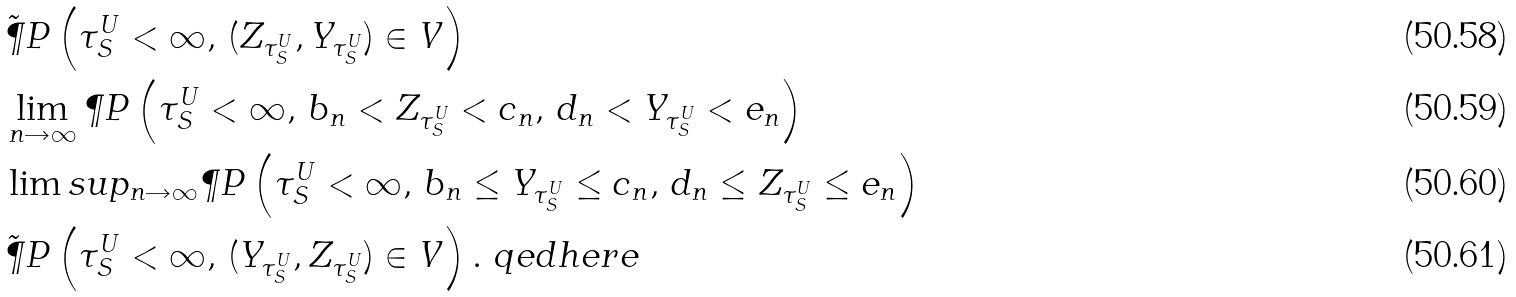<formula> <loc_0><loc_0><loc_500><loc_500>& \tilde { \P } P \left ( \tau ^ { U } _ { S } < \infty , \, ( Z _ { \tau ^ { U } _ { S } } , Y _ { \tau ^ { U } _ { S } } ) \in V \right ) \\ & \lim _ { n \rightarrow \infty } \P P \left ( \tau ^ { U } _ { S } < \infty , \, b _ { n } < Z _ { \tau ^ { U } _ { S } } < c _ { n } , \, d _ { n } < Y _ { \tau ^ { U } _ { S } } < e _ { n } \right ) \\ & \lim s u p _ { n \rightarrow \infty } \P P \left ( \tau ^ { U } _ { S } < \infty , \, b _ { n } \leq Y _ { \tau ^ { U } _ { S } } \leq c _ { n } , \, d _ { n } \leq Z _ { \tau ^ { U } _ { S } } \leq e _ { n } \right ) \\ & \tilde { \P } P \left ( \tau ^ { U } _ { S } < \infty , \, ( Y _ { \tau ^ { U } _ { S } } , Z _ { \tau ^ { U } _ { S } } ) \in V \right ) . \ q e d h e r e</formula> 